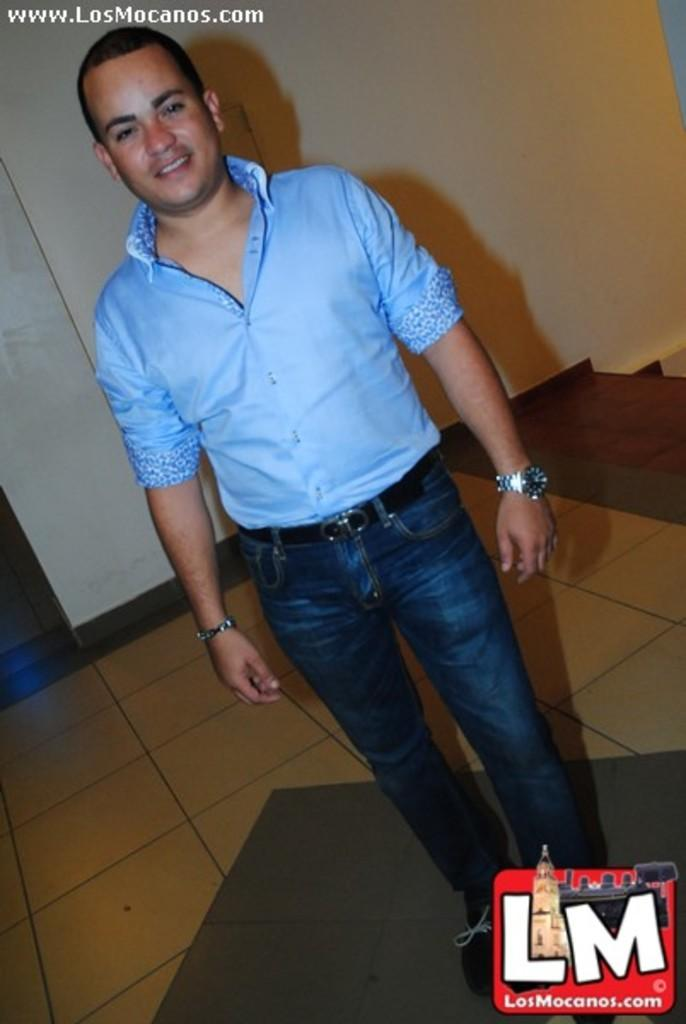What is the main subject of the image? There is a man standing in the middle of the image. What is the man's facial expression? The man is smiling. What is located behind the man in the image? There is a wall behind the man. Where can a logo be found in the image? The logo is in the bottom right side of the image. What type of zipper can be seen on the man's shirt in the image? There is no zipper visible on the man's shirt in the image. What kind of mark is present on the wall behind the man? There is no mark visible on the wall behind the man in the image. 